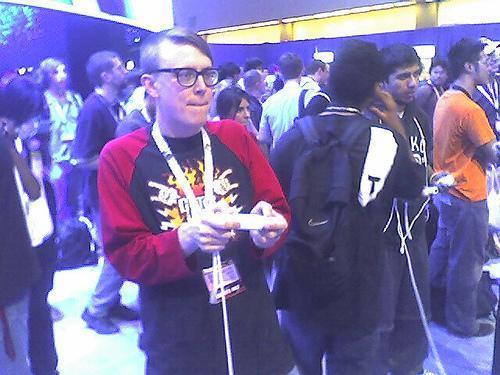How many people are there?
Give a very brief answer. 9. 